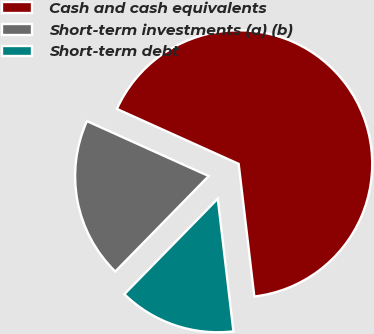Convert chart. <chart><loc_0><loc_0><loc_500><loc_500><pie_chart><fcel>Cash and cash equivalents<fcel>Short-term investments (a) (b)<fcel>Short-term debt<nl><fcel>66.38%<fcel>19.42%<fcel>14.2%<nl></chart> 